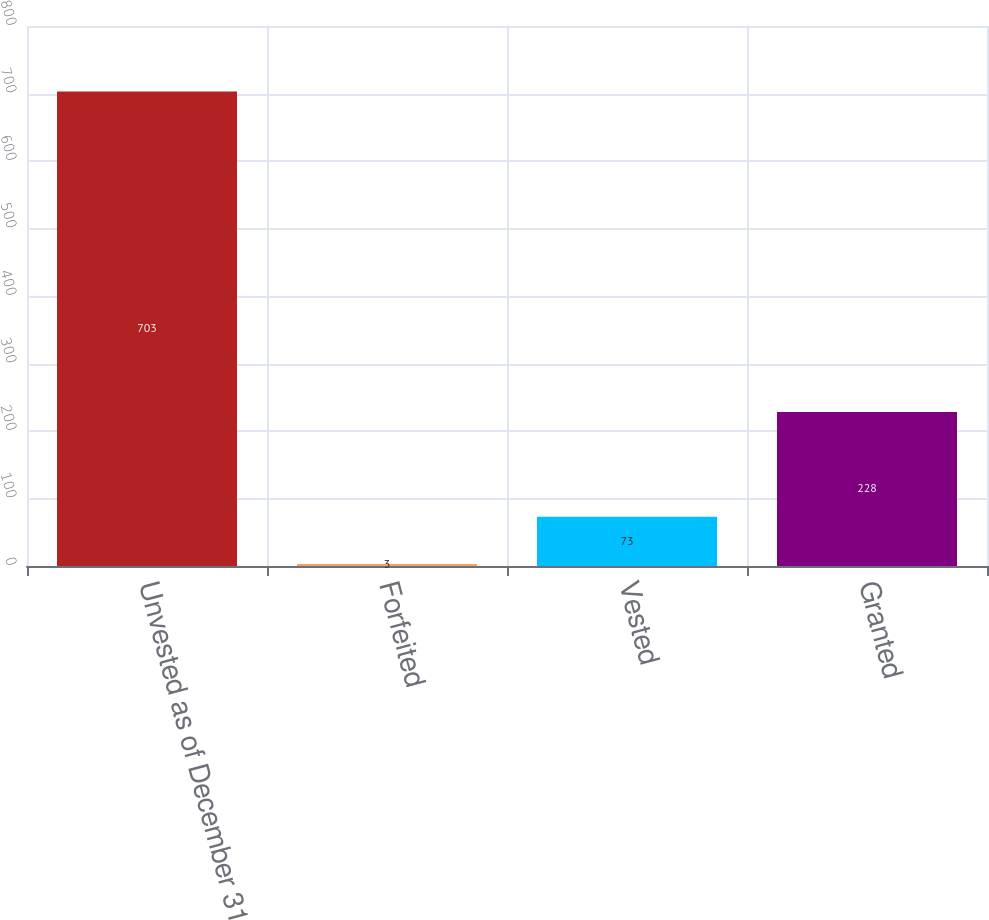<chart> <loc_0><loc_0><loc_500><loc_500><bar_chart><fcel>Unvested as of December 31<fcel>Forfeited<fcel>Vested<fcel>Granted<nl><fcel>703<fcel>3<fcel>73<fcel>228<nl></chart> 